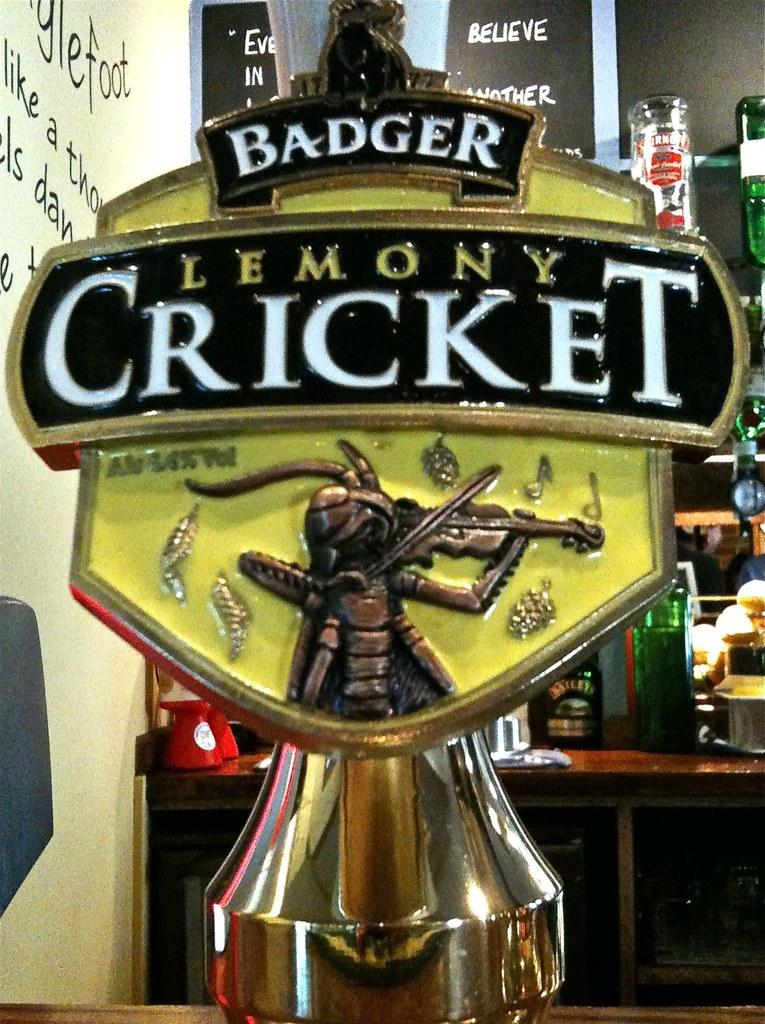<image>
Summarize the visual content of the image. a trophy item with the word cricket on it 